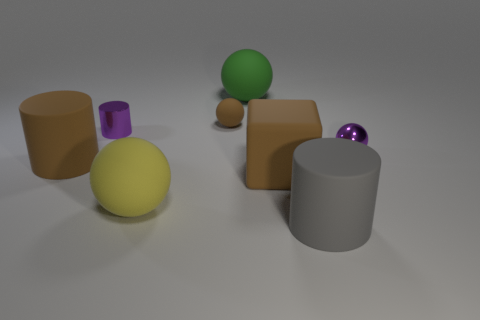Subtract all big cylinders. How many cylinders are left? 1 Add 2 big green metal balls. How many objects exist? 10 Subtract all brown balls. How many balls are left? 3 Subtract all cylinders. How many objects are left? 5 Add 2 big green rubber spheres. How many big green rubber spheres are left? 3 Add 1 small blue cylinders. How many small blue cylinders exist? 1 Subtract 1 green spheres. How many objects are left? 7 Subtract all green cubes. Subtract all red cylinders. How many cubes are left? 1 Subtract all brown matte cylinders. Subtract all large brown matte cylinders. How many objects are left? 6 